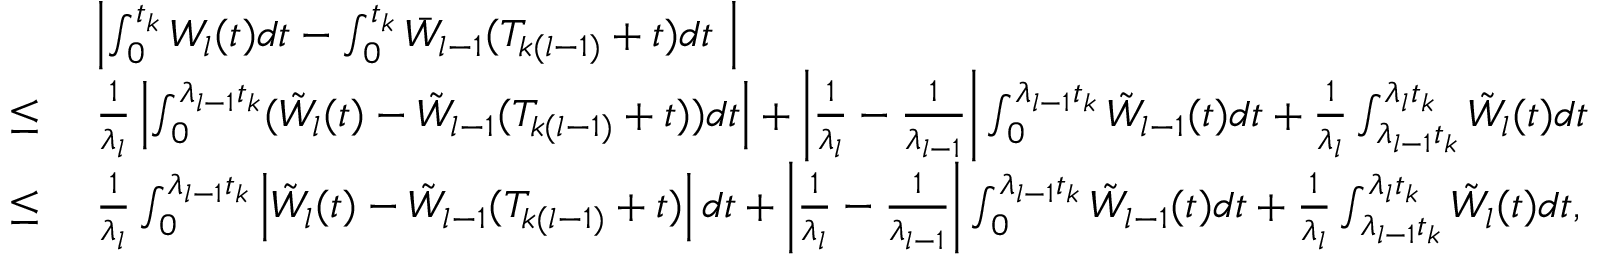<formula> <loc_0><loc_0><loc_500><loc_500>\begin{array} { r l } & { \left | \int _ { 0 } ^ { t _ { k } } W _ { l } ( t ) d t - \int _ { 0 } ^ { t _ { k } } \bar { W } _ { l - 1 } ( T _ { k ( l - 1 ) } + t ) d t \right | } \\ { \leq } & { \frac { 1 } { \lambda _ { l } } \left | \int _ { 0 } ^ { \lambda _ { l - 1 } t _ { k } } ( \tilde { W } _ { l } ( t ) - \tilde { W } _ { l - 1 } ( T _ { k ( l - 1 ) } + t ) ) d t \right | + \left | \frac { 1 } { \lambda _ { l } } - \frac { 1 } { \lambda _ { l - 1 } } \right | \int _ { 0 } ^ { \lambda _ { l - 1 } t _ { k } } \tilde { W } _ { l - 1 } ( t ) d t + \frac { 1 } { \lambda _ { l } } \int _ { \lambda _ { l - 1 } t _ { k } } ^ { \lambda _ { l } t _ { k } } \tilde { W } _ { l } ( t ) d t } \\ { \leq } & { \frac { 1 } { \lambda _ { l } } \int _ { 0 } ^ { \lambda _ { l - 1 } t _ { k } } \left | \tilde { W } _ { l } ( t ) - \tilde { W } _ { l - 1 } ( T _ { k ( l - 1 ) } + t ) \right | d t + \left | \frac { 1 } { \lambda _ { l } } - \frac { 1 } { \lambda _ { l - 1 } } \right | \int _ { 0 } ^ { \lambda _ { l - 1 } t _ { k } } \tilde { W } _ { l - 1 } ( t ) d t + \frac { 1 } { \lambda _ { l } } \int _ { \lambda _ { l - 1 } t _ { k } } ^ { \lambda _ { l } t _ { k } } \tilde { W } _ { l } ( t ) d t , } \end{array}</formula> 